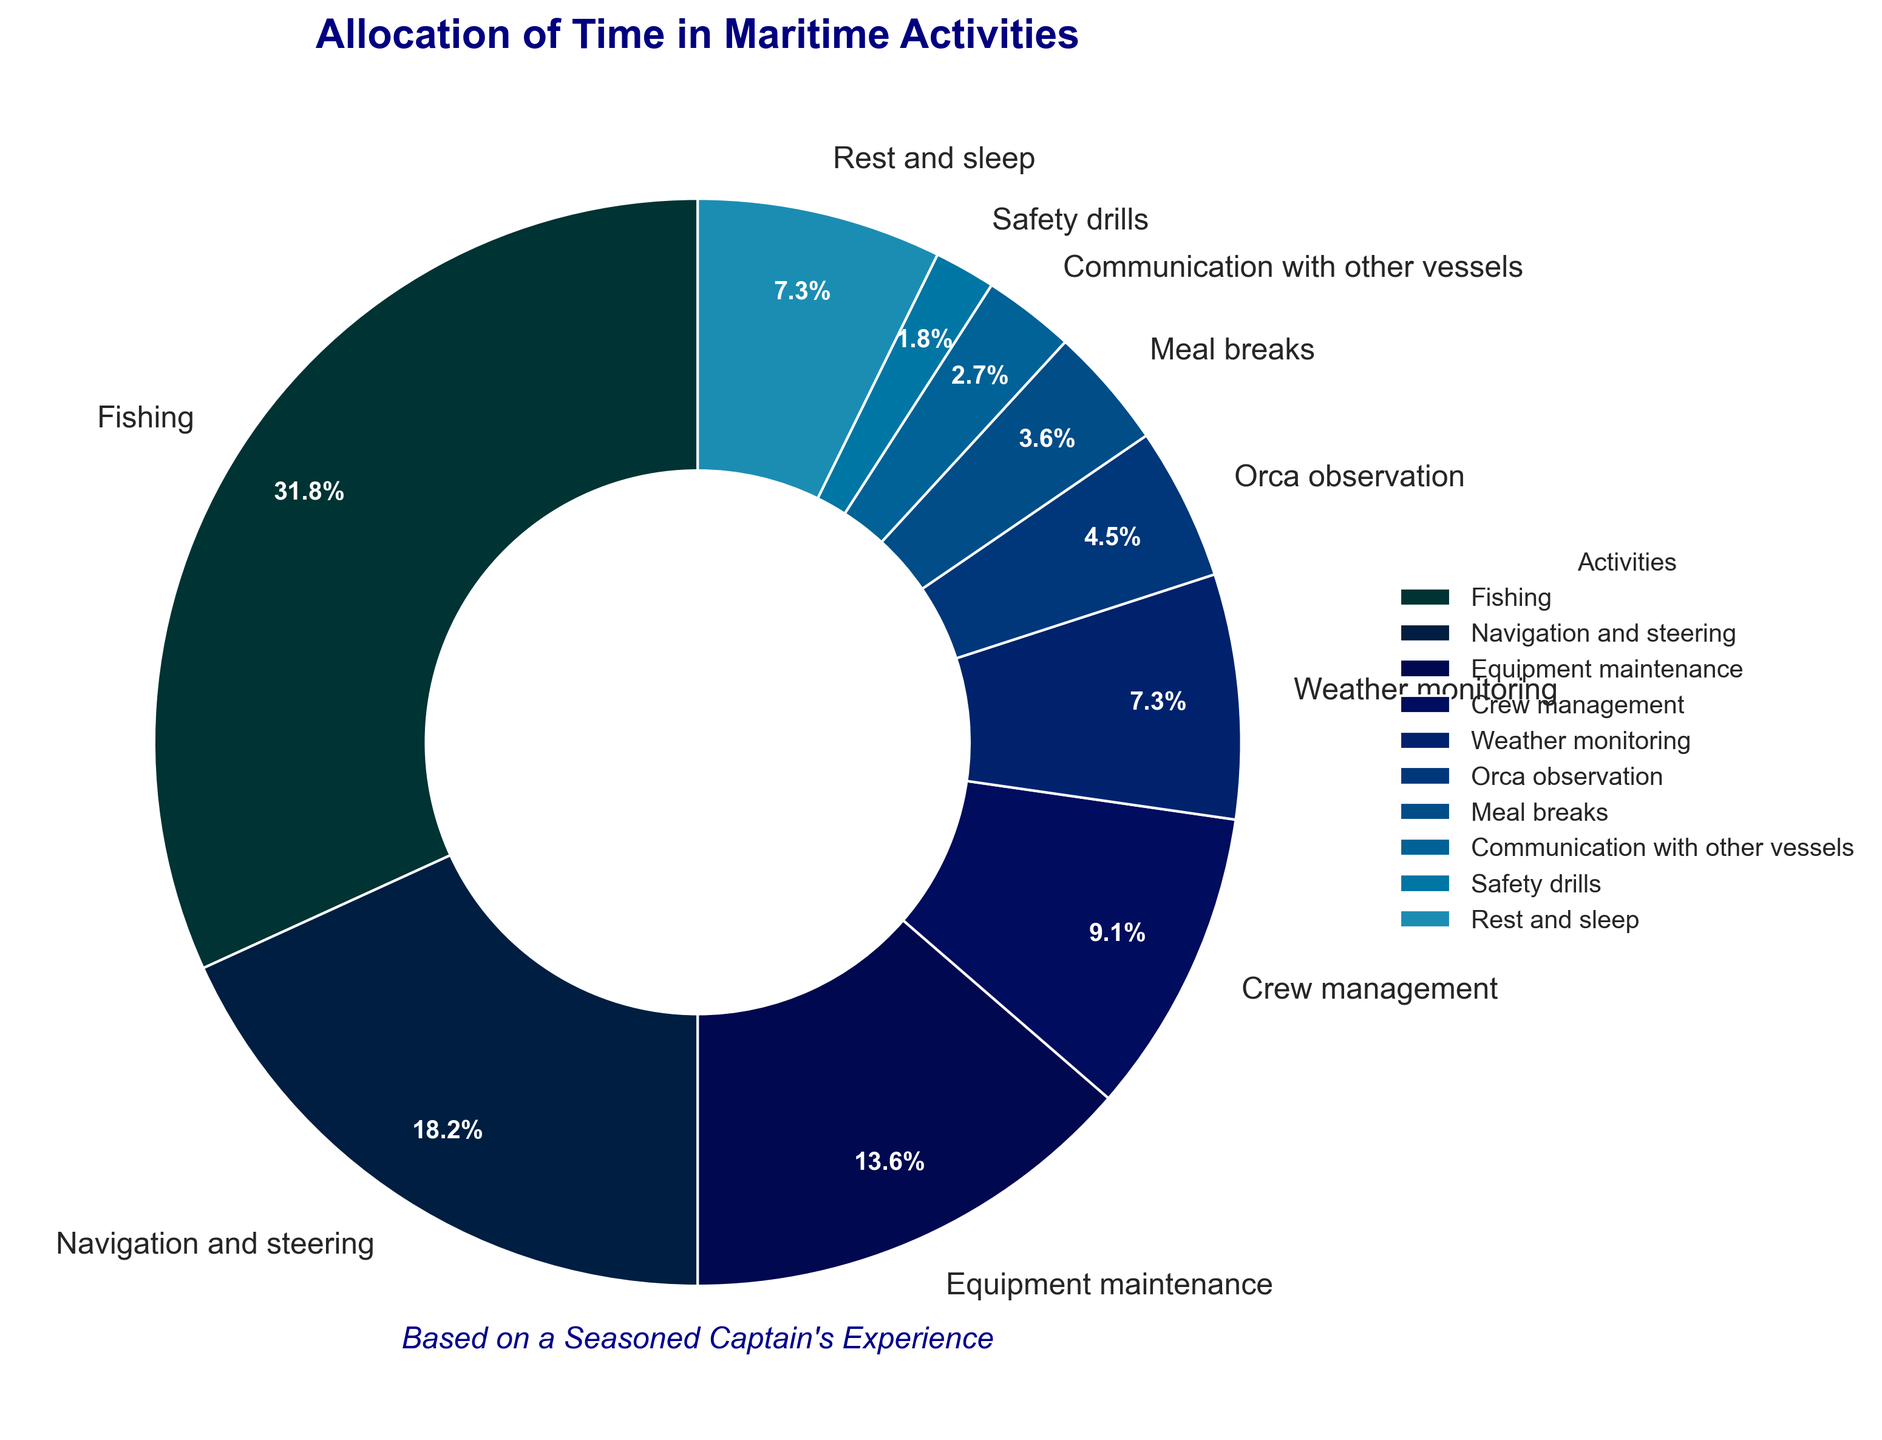What activity takes up the greatest percentage of time? To find the activity that takes up the greatest percentage of time, look for the label with the highest percentage. The figure shows that "Fishing" has the largest wedge.
Answer: Fishing What is the combined percentage for Navigation and steering and Weather monitoring? Add the percentages for both "Navigation and steering" (20%) and "Weather monitoring" (8%). 20% + 8% = 28%.
Answer: 28% Which activity takes up less time, Communication with other vessels or Safety drills? Compare the percentages for "Communication with other vessels" (3%) and "Safety drills" (2%). Since 3% is greater than 2%, "Safety drills" takes up less time.
Answer: Safety drills How does the percentage of Crew management compare to Orca observation? The percentage for "Crew management" is 10%, and for "Orca observation" it is 5%. Therefore, "Crew management" takes up twice as much time as "Orca observation".
Answer: Crew management takes up twice as much time If we were to combine the time spent on Meal breaks, Communication with other vessels, and Safety drills, what would be the total? Add the percentages for "Meal breaks" (4%), "Communication with other vessels" (3%), and "Safety drills" (2%). 4% + 3% + 2% = 9%.
Answer: 9% Which two activities, when combined, equal the time spent Fishing? Identify the two activities whose percentages add up to match the "Fishing" percentage (35%). "Navigation and steering" (20%) + "Crew management" (10%) + "Orca observation" (5%) = 35%.
Answer: Navigation and steering and Crew management and Orca observation Is the time spent on Equipment maintenance greater than, less than, or equal to the time spent on Rest and sleep? Compare the percentages for "Equipment maintenance" (15%) and "Rest and sleep" (8%). Since 15% is greater than 8%, "Equipment maintenance" takes up more time.
Answer: Greater than What percentage of time is not spent on Fishing, Navigation and steering, and Equipment maintenance combined? Subtract the combined percentage of "Fishing" (35%), "Navigation and steering" (20%), and "Equipment maintenance" (15%) from 100%. 35% + 20% + 15% = 70%; 100% - 70% = 30%.
Answer: 30% 